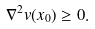<formula> <loc_0><loc_0><loc_500><loc_500>\nabla ^ { 2 } v ( x _ { 0 } ) \geq 0 .</formula> 